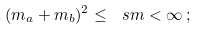<formula> <loc_0><loc_0><loc_500><loc_500>( m _ { a } + m _ { b } ) ^ { 2 } \leq \ s m < \infty \, ;</formula> 